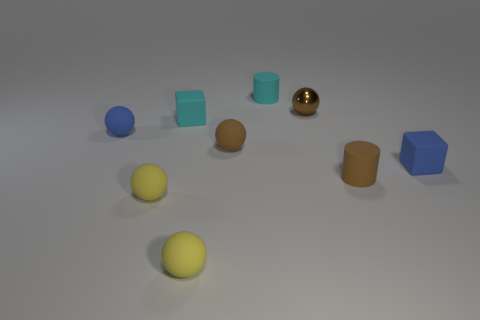Subtract all blue spheres. How many spheres are left? 4 Subtract all green spheres. Subtract all brown cubes. How many spheres are left? 5 Add 1 blue matte blocks. How many objects exist? 10 Subtract all cylinders. How many objects are left? 7 Add 1 tiny brown rubber spheres. How many tiny brown rubber spheres are left? 2 Add 6 small blue blocks. How many small blue blocks exist? 7 Subtract 0 red balls. How many objects are left? 9 Subtract all small gray balls. Subtract all blue matte things. How many objects are left? 7 